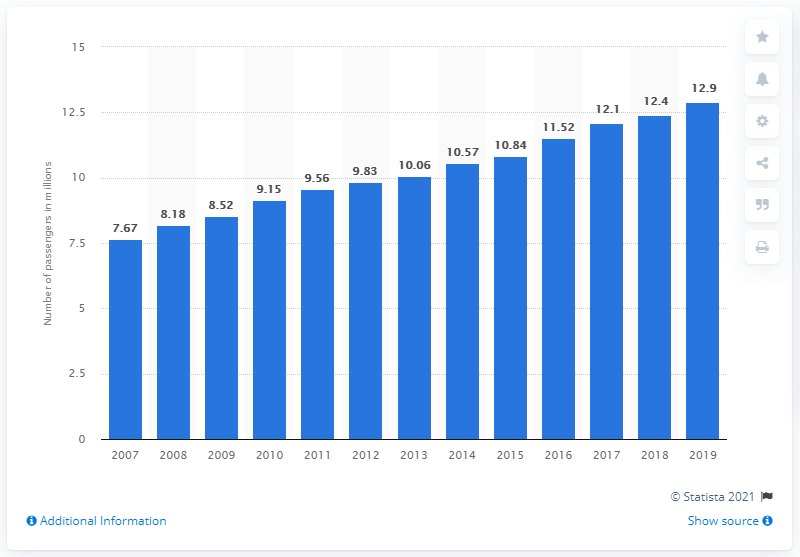Indicate a few pertinent items in this graphic. In 2019, Carnival Corporation transported a total of 12,900 passengers on its ships. 